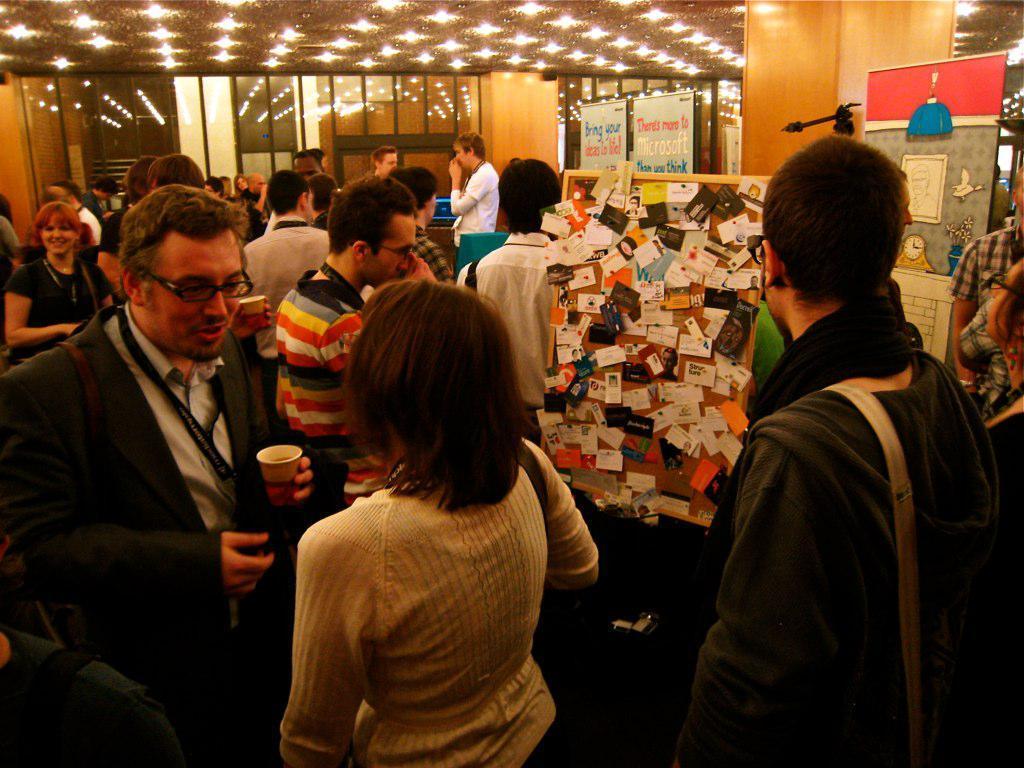Describe this image in one or two sentences. In the middle of the image few people are standing and holding some cups. Behind them there are some banners and wall. At the top of the image there is ceiling and lights. 